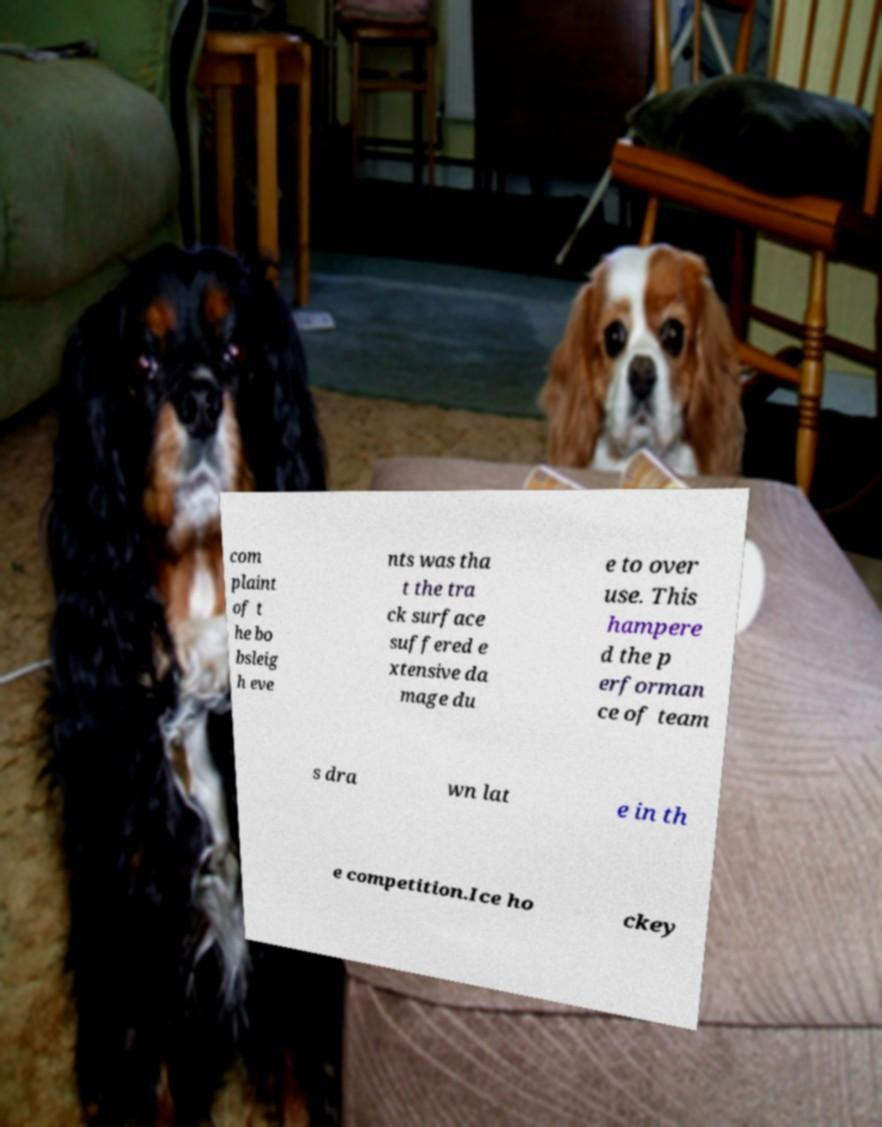Could you assist in decoding the text presented in this image and type it out clearly? com plaint of t he bo bsleig h eve nts was tha t the tra ck surface suffered e xtensive da mage du e to over use. This hampere d the p erforman ce of team s dra wn lat e in th e competition.Ice ho ckey 